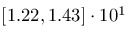Convert formula to latex. <formula><loc_0><loc_0><loc_500><loc_500>\left [ 1 . 2 2 , 1 . 4 3 \right ] \cdot 1 0 ^ { 1 }</formula> 